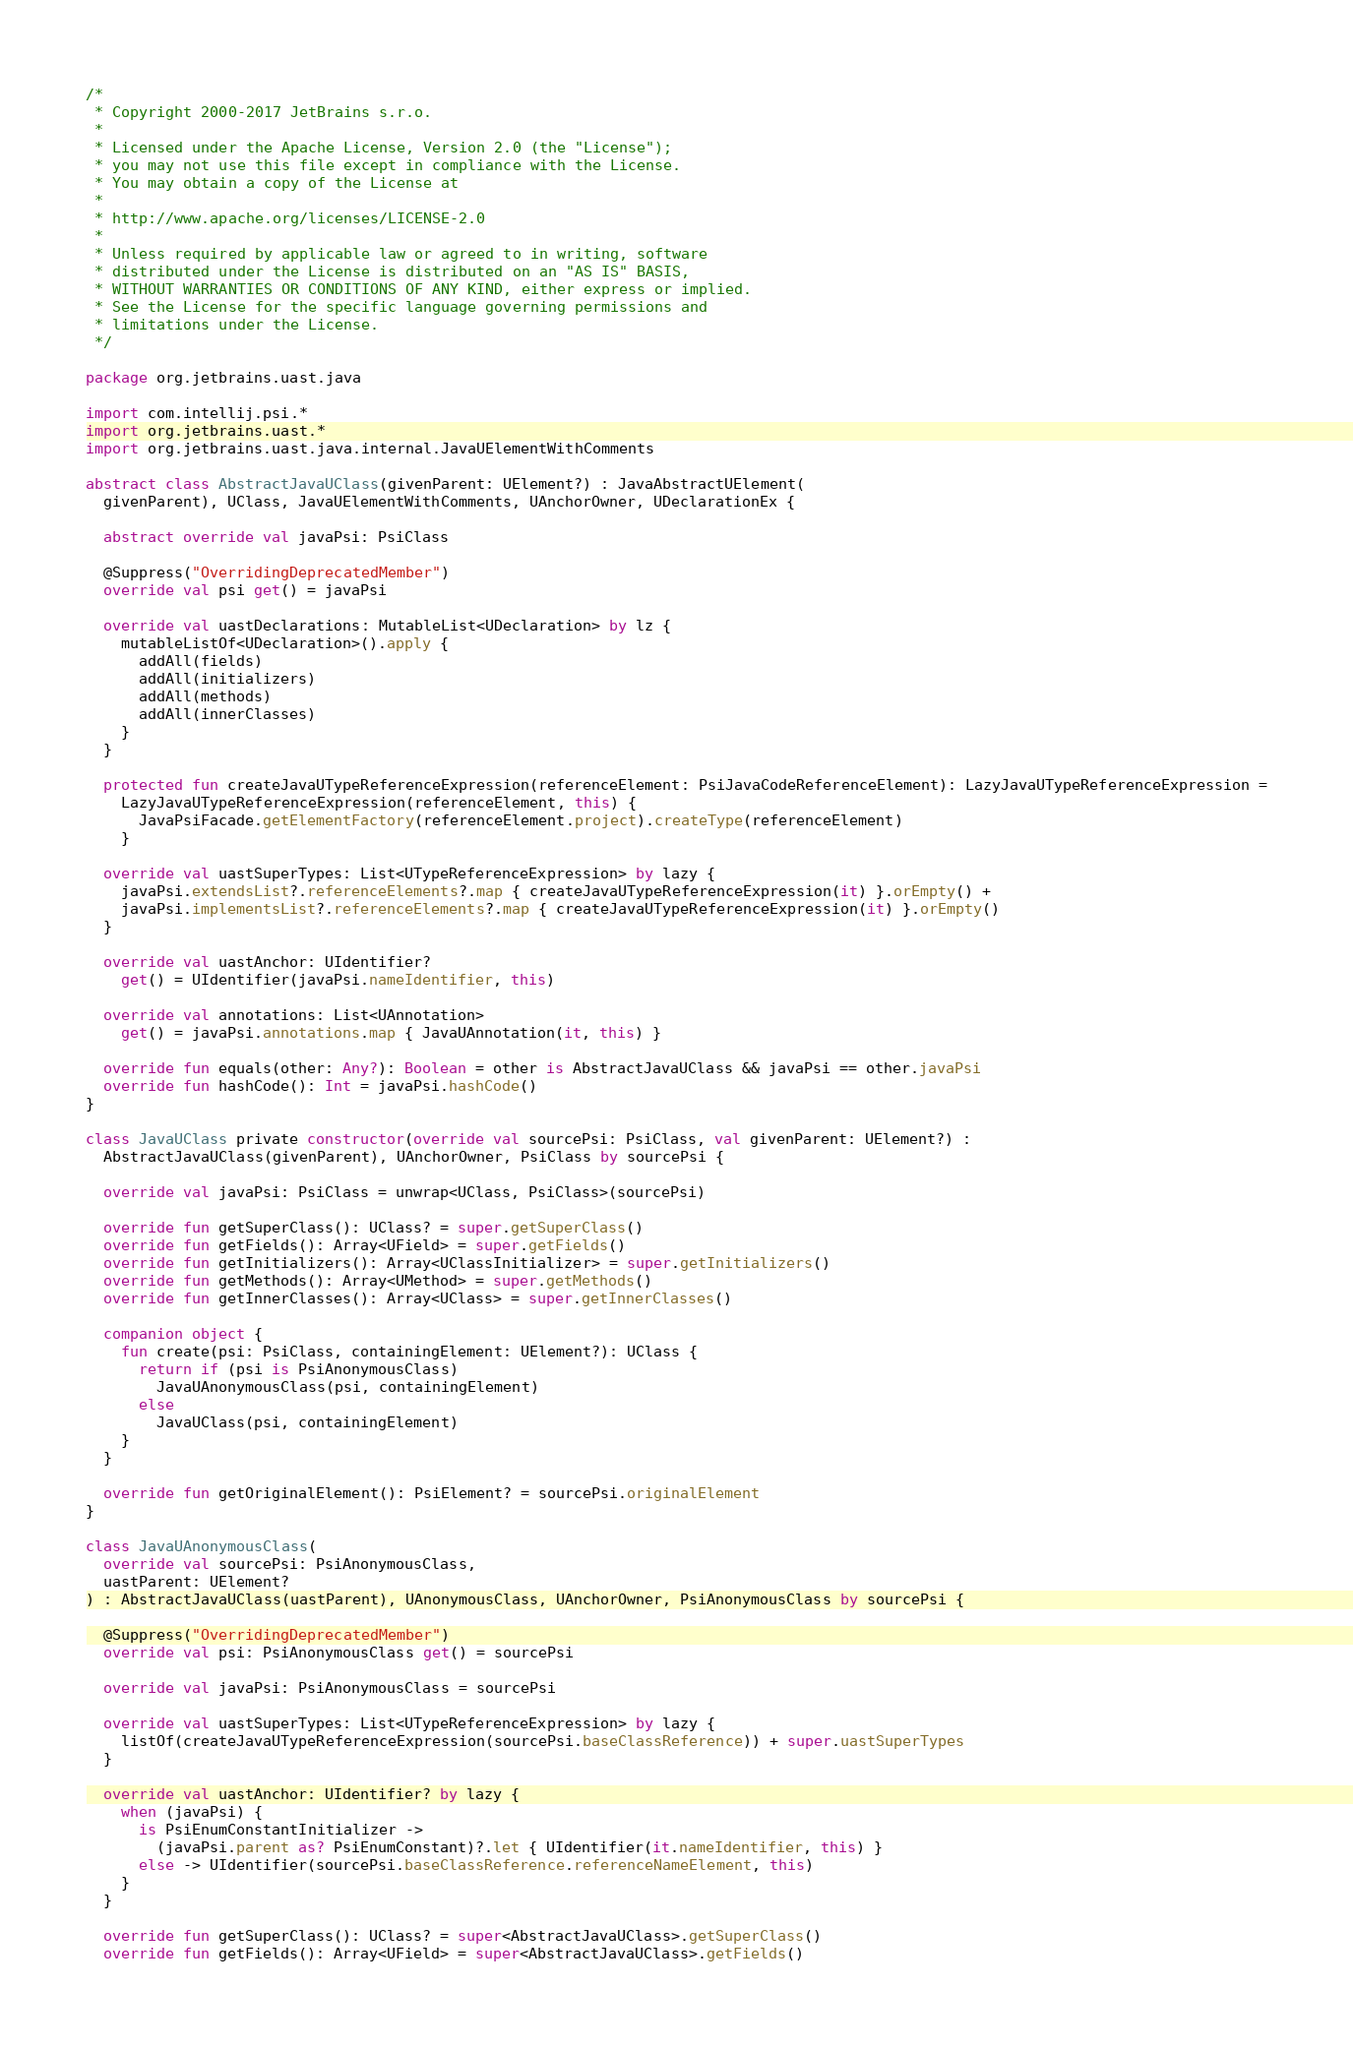Convert code to text. <code><loc_0><loc_0><loc_500><loc_500><_Kotlin_>/*
 * Copyright 2000-2017 JetBrains s.r.o.
 *
 * Licensed under the Apache License, Version 2.0 (the "License");
 * you may not use this file except in compliance with the License.
 * You may obtain a copy of the License at
 *
 * http://www.apache.org/licenses/LICENSE-2.0
 *
 * Unless required by applicable law or agreed to in writing, software
 * distributed under the License is distributed on an "AS IS" BASIS,
 * WITHOUT WARRANTIES OR CONDITIONS OF ANY KIND, either express or implied.
 * See the License for the specific language governing permissions and
 * limitations under the License.
 */

package org.jetbrains.uast.java

import com.intellij.psi.*
import org.jetbrains.uast.*
import org.jetbrains.uast.java.internal.JavaUElementWithComments

abstract class AbstractJavaUClass(givenParent: UElement?) : JavaAbstractUElement(
  givenParent), UClass, JavaUElementWithComments, UAnchorOwner, UDeclarationEx {

  abstract override val javaPsi: PsiClass

  @Suppress("OverridingDeprecatedMember")
  override val psi get() = javaPsi

  override val uastDeclarations: MutableList<UDeclaration> by lz {
    mutableListOf<UDeclaration>().apply {
      addAll(fields)
      addAll(initializers)
      addAll(methods)
      addAll(innerClasses)
    }
  }

  protected fun createJavaUTypeReferenceExpression(referenceElement: PsiJavaCodeReferenceElement): LazyJavaUTypeReferenceExpression =
    LazyJavaUTypeReferenceExpression(referenceElement, this) {
      JavaPsiFacade.getElementFactory(referenceElement.project).createType(referenceElement)
    }

  override val uastSuperTypes: List<UTypeReferenceExpression> by lazy {
    javaPsi.extendsList?.referenceElements?.map { createJavaUTypeReferenceExpression(it) }.orEmpty() +
    javaPsi.implementsList?.referenceElements?.map { createJavaUTypeReferenceExpression(it) }.orEmpty()
  }

  override val uastAnchor: UIdentifier?
    get() = UIdentifier(javaPsi.nameIdentifier, this)

  override val annotations: List<UAnnotation>
    get() = javaPsi.annotations.map { JavaUAnnotation(it, this) }

  override fun equals(other: Any?): Boolean = other is AbstractJavaUClass && javaPsi == other.javaPsi
  override fun hashCode(): Int = javaPsi.hashCode()
}

class JavaUClass private constructor(override val sourcePsi: PsiClass, val givenParent: UElement?) :
  AbstractJavaUClass(givenParent), UAnchorOwner, PsiClass by sourcePsi {

  override val javaPsi: PsiClass = unwrap<UClass, PsiClass>(sourcePsi)

  override fun getSuperClass(): UClass? = super.getSuperClass()
  override fun getFields(): Array<UField> = super.getFields()
  override fun getInitializers(): Array<UClassInitializer> = super.getInitializers()
  override fun getMethods(): Array<UMethod> = super.getMethods()
  override fun getInnerClasses(): Array<UClass> = super.getInnerClasses()

  companion object {
    fun create(psi: PsiClass, containingElement: UElement?): UClass {
      return if (psi is PsiAnonymousClass)
        JavaUAnonymousClass(psi, containingElement)
      else
        JavaUClass(psi, containingElement)
    }
  }

  override fun getOriginalElement(): PsiElement? = sourcePsi.originalElement
}

class JavaUAnonymousClass(
  override val sourcePsi: PsiAnonymousClass,
  uastParent: UElement?
) : AbstractJavaUClass(uastParent), UAnonymousClass, UAnchorOwner, PsiAnonymousClass by sourcePsi {

  @Suppress("OverridingDeprecatedMember")
  override val psi: PsiAnonymousClass get() = sourcePsi

  override val javaPsi: PsiAnonymousClass = sourcePsi

  override val uastSuperTypes: List<UTypeReferenceExpression> by lazy {
    listOf(createJavaUTypeReferenceExpression(sourcePsi.baseClassReference)) + super.uastSuperTypes
  }

  override val uastAnchor: UIdentifier? by lazy {
    when (javaPsi) {
      is PsiEnumConstantInitializer ->
        (javaPsi.parent as? PsiEnumConstant)?.let { UIdentifier(it.nameIdentifier, this) }
      else -> UIdentifier(sourcePsi.baseClassReference.referenceNameElement, this)
    }
  }

  override fun getSuperClass(): UClass? = super<AbstractJavaUClass>.getSuperClass()
  override fun getFields(): Array<UField> = super<AbstractJavaUClass>.getFields()</code> 